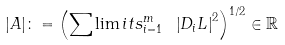<formula> <loc_0><loc_0><loc_500><loc_500>| A | \colon = \left ( \sum \lim i t s _ { i = 1 } ^ { m } \text { } \left | D _ { i } L \right | ^ { 2 } \right ) ^ { 1 / 2 } \in \mathbb { R }</formula> 